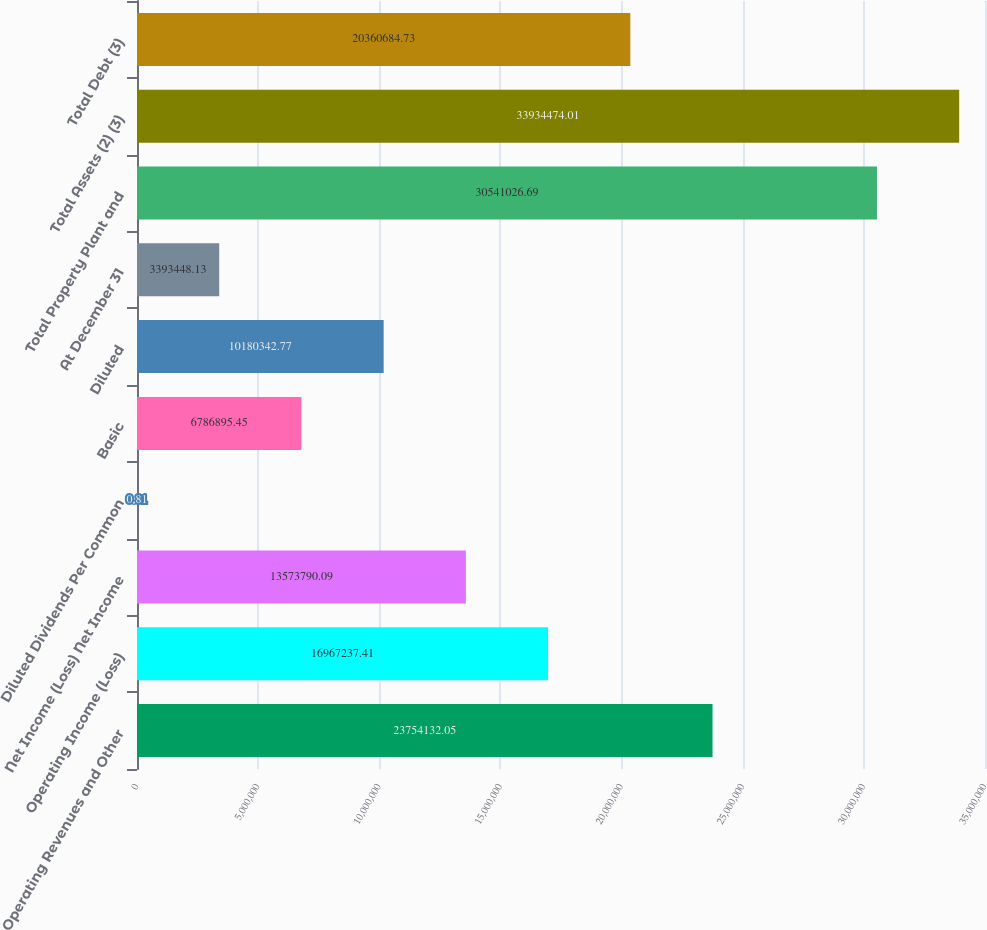Convert chart to OTSL. <chart><loc_0><loc_0><loc_500><loc_500><bar_chart><fcel>Operating Revenues and Other<fcel>Operating Income (Loss)<fcel>Net Income (Loss) Net Income<fcel>Diluted Dividends Per Common<fcel>Basic<fcel>Diluted<fcel>At December 31<fcel>Total Property Plant and<fcel>Total Assets (2) (3)<fcel>Total Debt (3)<nl><fcel>2.37541e+07<fcel>1.69672e+07<fcel>1.35738e+07<fcel>0.81<fcel>6.7869e+06<fcel>1.01803e+07<fcel>3.39345e+06<fcel>3.0541e+07<fcel>3.39345e+07<fcel>2.03607e+07<nl></chart> 